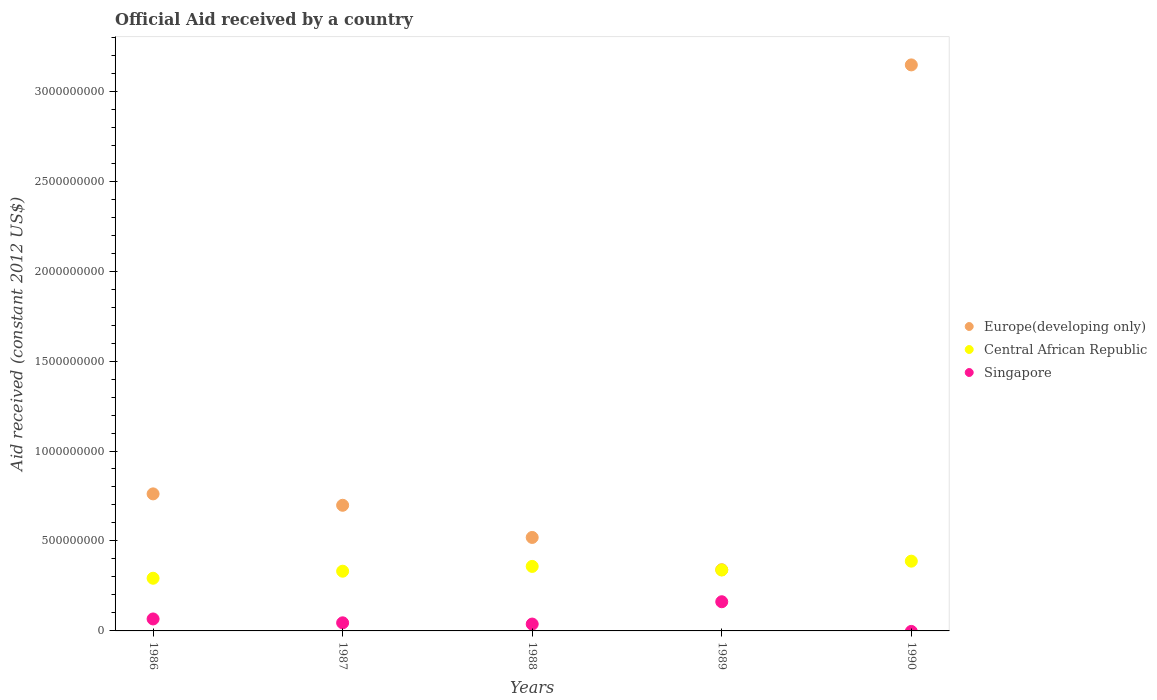What is the net official aid received in Central African Republic in 1986?
Give a very brief answer. 2.93e+08. Across all years, what is the maximum net official aid received in Europe(developing only)?
Keep it short and to the point. 3.15e+09. Across all years, what is the minimum net official aid received in Europe(developing only)?
Keep it short and to the point. 3.40e+08. What is the total net official aid received in Singapore in the graph?
Your answer should be very brief. 3.12e+08. What is the difference between the net official aid received in Europe(developing only) in 1986 and that in 1989?
Your response must be concise. 4.22e+08. What is the difference between the net official aid received in Europe(developing only) in 1986 and the net official aid received in Singapore in 1990?
Ensure brevity in your answer.  7.62e+08. What is the average net official aid received in Singapore per year?
Keep it short and to the point. 6.24e+07. In the year 1990, what is the difference between the net official aid received in Europe(developing only) and net official aid received in Central African Republic?
Keep it short and to the point. 2.76e+09. In how many years, is the net official aid received in Singapore greater than 3100000000 US$?
Ensure brevity in your answer.  0. What is the ratio of the net official aid received in Central African Republic in 1987 to that in 1988?
Your answer should be compact. 0.93. What is the difference between the highest and the second highest net official aid received in Singapore?
Provide a short and direct response. 9.56e+07. What is the difference between the highest and the lowest net official aid received in Singapore?
Ensure brevity in your answer.  1.62e+08. Is the sum of the net official aid received in Central African Republic in 1988 and 1989 greater than the maximum net official aid received in Singapore across all years?
Offer a terse response. Yes. Is it the case that in every year, the sum of the net official aid received in Central African Republic and net official aid received in Singapore  is greater than the net official aid received in Europe(developing only)?
Offer a very short reply. No. Is the net official aid received in Singapore strictly greater than the net official aid received in Central African Republic over the years?
Your answer should be compact. No. Are the values on the major ticks of Y-axis written in scientific E-notation?
Offer a terse response. No. Where does the legend appear in the graph?
Provide a short and direct response. Center right. How many legend labels are there?
Offer a terse response. 3. How are the legend labels stacked?
Your response must be concise. Vertical. What is the title of the graph?
Give a very brief answer. Official Aid received by a country. Does "High income: nonOECD" appear as one of the legend labels in the graph?
Provide a short and direct response. No. What is the label or title of the X-axis?
Your response must be concise. Years. What is the label or title of the Y-axis?
Your answer should be compact. Aid received (constant 2012 US$). What is the Aid received (constant 2012 US$) of Europe(developing only) in 1986?
Provide a succinct answer. 7.62e+08. What is the Aid received (constant 2012 US$) in Central African Republic in 1986?
Ensure brevity in your answer.  2.93e+08. What is the Aid received (constant 2012 US$) in Singapore in 1986?
Make the answer very short. 6.65e+07. What is the Aid received (constant 2012 US$) in Europe(developing only) in 1987?
Your response must be concise. 6.98e+08. What is the Aid received (constant 2012 US$) in Central African Republic in 1987?
Your response must be concise. 3.32e+08. What is the Aid received (constant 2012 US$) of Singapore in 1987?
Keep it short and to the point. 4.50e+07. What is the Aid received (constant 2012 US$) in Europe(developing only) in 1988?
Ensure brevity in your answer.  5.20e+08. What is the Aid received (constant 2012 US$) of Central African Republic in 1988?
Provide a short and direct response. 3.59e+08. What is the Aid received (constant 2012 US$) of Singapore in 1988?
Keep it short and to the point. 3.82e+07. What is the Aid received (constant 2012 US$) in Europe(developing only) in 1989?
Your answer should be compact. 3.40e+08. What is the Aid received (constant 2012 US$) of Central African Republic in 1989?
Provide a succinct answer. 3.39e+08. What is the Aid received (constant 2012 US$) in Singapore in 1989?
Provide a succinct answer. 1.62e+08. What is the Aid received (constant 2012 US$) of Europe(developing only) in 1990?
Provide a succinct answer. 3.15e+09. What is the Aid received (constant 2012 US$) in Central African Republic in 1990?
Your answer should be very brief. 3.88e+08. What is the Aid received (constant 2012 US$) of Singapore in 1990?
Make the answer very short. 0. Across all years, what is the maximum Aid received (constant 2012 US$) in Europe(developing only)?
Make the answer very short. 3.15e+09. Across all years, what is the maximum Aid received (constant 2012 US$) in Central African Republic?
Offer a terse response. 3.88e+08. Across all years, what is the maximum Aid received (constant 2012 US$) of Singapore?
Offer a very short reply. 1.62e+08. Across all years, what is the minimum Aid received (constant 2012 US$) of Europe(developing only)?
Provide a succinct answer. 3.40e+08. Across all years, what is the minimum Aid received (constant 2012 US$) of Central African Republic?
Provide a succinct answer. 2.93e+08. What is the total Aid received (constant 2012 US$) in Europe(developing only) in the graph?
Offer a terse response. 5.47e+09. What is the total Aid received (constant 2012 US$) in Central African Republic in the graph?
Keep it short and to the point. 1.71e+09. What is the total Aid received (constant 2012 US$) in Singapore in the graph?
Ensure brevity in your answer.  3.12e+08. What is the difference between the Aid received (constant 2012 US$) of Europe(developing only) in 1986 and that in 1987?
Give a very brief answer. 6.33e+07. What is the difference between the Aid received (constant 2012 US$) in Central African Republic in 1986 and that in 1987?
Your answer should be compact. -3.91e+07. What is the difference between the Aid received (constant 2012 US$) in Singapore in 1986 and that in 1987?
Offer a very short reply. 2.15e+07. What is the difference between the Aid received (constant 2012 US$) of Europe(developing only) in 1986 and that in 1988?
Your answer should be very brief. 2.42e+08. What is the difference between the Aid received (constant 2012 US$) of Central African Republic in 1986 and that in 1988?
Offer a terse response. -6.58e+07. What is the difference between the Aid received (constant 2012 US$) of Singapore in 1986 and that in 1988?
Ensure brevity in your answer.  2.84e+07. What is the difference between the Aid received (constant 2012 US$) of Europe(developing only) in 1986 and that in 1989?
Your response must be concise. 4.22e+08. What is the difference between the Aid received (constant 2012 US$) in Central African Republic in 1986 and that in 1989?
Your answer should be compact. -4.58e+07. What is the difference between the Aid received (constant 2012 US$) in Singapore in 1986 and that in 1989?
Provide a short and direct response. -9.56e+07. What is the difference between the Aid received (constant 2012 US$) of Europe(developing only) in 1986 and that in 1990?
Give a very brief answer. -2.38e+09. What is the difference between the Aid received (constant 2012 US$) of Central African Republic in 1986 and that in 1990?
Provide a succinct answer. -9.49e+07. What is the difference between the Aid received (constant 2012 US$) of Europe(developing only) in 1987 and that in 1988?
Make the answer very short. 1.79e+08. What is the difference between the Aid received (constant 2012 US$) of Central African Republic in 1987 and that in 1988?
Offer a very short reply. -2.67e+07. What is the difference between the Aid received (constant 2012 US$) of Singapore in 1987 and that in 1988?
Your response must be concise. 6.88e+06. What is the difference between the Aid received (constant 2012 US$) of Europe(developing only) in 1987 and that in 1989?
Offer a terse response. 3.58e+08. What is the difference between the Aid received (constant 2012 US$) of Central African Republic in 1987 and that in 1989?
Make the answer very short. -6.66e+06. What is the difference between the Aid received (constant 2012 US$) in Singapore in 1987 and that in 1989?
Offer a terse response. -1.17e+08. What is the difference between the Aid received (constant 2012 US$) of Europe(developing only) in 1987 and that in 1990?
Offer a terse response. -2.45e+09. What is the difference between the Aid received (constant 2012 US$) in Central African Republic in 1987 and that in 1990?
Offer a terse response. -5.58e+07. What is the difference between the Aid received (constant 2012 US$) of Europe(developing only) in 1988 and that in 1989?
Ensure brevity in your answer.  1.79e+08. What is the difference between the Aid received (constant 2012 US$) of Central African Republic in 1988 and that in 1989?
Your response must be concise. 2.00e+07. What is the difference between the Aid received (constant 2012 US$) in Singapore in 1988 and that in 1989?
Your response must be concise. -1.24e+08. What is the difference between the Aid received (constant 2012 US$) in Europe(developing only) in 1988 and that in 1990?
Your response must be concise. -2.63e+09. What is the difference between the Aid received (constant 2012 US$) in Central African Republic in 1988 and that in 1990?
Your answer should be very brief. -2.91e+07. What is the difference between the Aid received (constant 2012 US$) of Europe(developing only) in 1989 and that in 1990?
Ensure brevity in your answer.  -2.81e+09. What is the difference between the Aid received (constant 2012 US$) in Central African Republic in 1989 and that in 1990?
Give a very brief answer. -4.92e+07. What is the difference between the Aid received (constant 2012 US$) of Europe(developing only) in 1986 and the Aid received (constant 2012 US$) of Central African Republic in 1987?
Provide a succinct answer. 4.30e+08. What is the difference between the Aid received (constant 2012 US$) in Europe(developing only) in 1986 and the Aid received (constant 2012 US$) in Singapore in 1987?
Offer a terse response. 7.17e+08. What is the difference between the Aid received (constant 2012 US$) in Central African Republic in 1986 and the Aid received (constant 2012 US$) in Singapore in 1987?
Ensure brevity in your answer.  2.48e+08. What is the difference between the Aid received (constant 2012 US$) of Europe(developing only) in 1986 and the Aid received (constant 2012 US$) of Central African Republic in 1988?
Ensure brevity in your answer.  4.03e+08. What is the difference between the Aid received (constant 2012 US$) in Europe(developing only) in 1986 and the Aid received (constant 2012 US$) in Singapore in 1988?
Make the answer very short. 7.24e+08. What is the difference between the Aid received (constant 2012 US$) in Central African Republic in 1986 and the Aid received (constant 2012 US$) in Singapore in 1988?
Provide a short and direct response. 2.55e+08. What is the difference between the Aid received (constant 2012 US$) of Europe(developing only) in 1986 and the Aid received (constant 2012 US$) of Central African Republic in 1989?
Provide a short and direct response. 4.23e+08. What is the difference between the Aid received (constant 2012 US$) in Europe(developing only) in 1986 and the Aid received (constant 2012 US$) in Singapore in 1989?
Offer a terse response. 6.00e+08. What is the difference between the Aid received (constant 2012 US$) in Central African Republic in 1986 and the Aid received (constant 2012 US$) in Singapore in 1989?
Your response must be concise. 1.31e+08. What is the difference between the Aid received (constant 2012 US$) of Europe(developing only) in 1986 and the Aid received (constant 2012 US$) of Central African Republic in 1990?
Offer a terse response. 3.74e+08. What is the difference between the Aid received (constant 2012 US$) of Europe(developing only) in 1987 and the Aid received (constant 2012 US$) of Central African Republic in 1988?
Provide a short and direct response. 3.40e+08. What is the difference between the Aid received (constant 2012 US$) in Europe(developing only) in 1987 and the Aid received (constant 2012 US$) in Singapore in 1988?
Your response must be concise. 6.60e+08. What is the difference between the Aid received (constant 2012 US$) in Central African Republic in 1987 and the Aid received (constant 2012 US$) in Singapore in 1988?
Keep it short and to the point. 2.94e+08. What is the difference between the Aid received (constant 2012 US$) in Europe(developing only) in 1987 and the Aid received (constant 2012 US$) in Central African Republic in 1989?
Provide a succinct answer. 3.60e+08. What is the difference between the Aid received (constant 2012 US$) in Europe(developing only) in 1987 and the Aid received (constant 2012 US$) in Singapore in 1989?
Keep it short and to the point. 5.36e+08. What is the difference between the Aid received (constant 2012 US$) of Central African Republic in 1987 and the Aid received (constant 2012 US$) of Singapore in 1989?
Ensure brevity in your answer.  1.70e+08. What is the difference between the Aid received (constant 2012 US$) of Europe(developing only) in 1987 and the Aid received (constant 2012 US$) of Central African Republic in 1990?
Offer a terse response. 3.11e+08. What is the difference between the Aid received (constant 2012 US$) of Europe(developing only) in 1988 and the Aid received (constant 2012 US$) of Central African Republic in 1989?
Make the answer very short. 1.81e+08. What is the difference between the Aid received (constant 2012 US$) of Europe(developing only) in 1988 and the Aid received (constant 2012 US$) of Singapore in 1989?
Your answer should be very brief. 3.57e+08. What is the difference between the Aid received (constant 2012 US$) in Central African Republic in 1988 and the Aid received (constant 2012 US$) in Singapore in 1989?
Your response must be concise. 1.96e+08. What is the difference between the Aid received (constant 2012 US$) of Europe(developing only) in 1988 and the Aid received (constant 2012 US$) of Central African Republic in 1990?
Your answer should be compact. 1.32e+08. What is the difference between the Aid received (constant 2012 US$) of Europe(developing only) in 1989 and the Aid received (constant 2012 US$) of Central African Republic in 1990?
Make the answer very short. -4.76e+07. What is the average Aid received (constant 2012 US$) of Europe(developing only) per year?
Provide a short and direct response. 1.09e+09. What is the average Aid received (constant 2012 US$) of Central African Republic per year?
Keep it short and to the point. 3.42e+08. What is the average Aid received (constant 2012 US$) in Singapore per year?
Offer a terse response. 6.24e+07. In the year 1986, what is the difference between the Aid received (constant 2012 US$) of Europe(developing only) and Aid received (constant 2012 US$) of Central African Republic?
Provide a short and direct response. 4.69e+08. In the year 1986, what is the difference between the Aid received (constant 2012 US$) of Europe(developing only) and Aid received (constant 2012 US$) of Singapore?
Provide a short and direct response. 6.95e+08. In the year 1986, what is the difference between the Aid received (constant 2012 US$) in Central African Republic and Aid received (constant 2012 US$) in Singapore?
Ensure brevity in your answer.  2.26e+08. In the year 1987, what is the difference between the Aid received (constant 2012 US$) in Europe(developing only) and Aid received (constant 2012 US$) in Central African Republic?
Your answer should be very brief. 3.66e+08. In the year 1987, what is the difference between the Aid received (constant 2012 US$) of Europe(developing only) and Aid received (constant 2012 US$) of Singapore?
Your response must be concise. 6.53e+08. In the year 1987, what is the difference between the Aid received (constant 2012 US$) in Central African Republic and Aid received (constant 2012 US$) in Singapore?
Ensure brevity in your answer.  2.87e+08. In the year 1988, what is the difference between the Aid received (constant 2012 US$) of Europe(developing only) and Aid received (constant 2012 US$) of Central African Republic?
Your answer should be compact. 1.61e+08. In the year 1988, what is the difference between the Aid received (constant 2012 US$) in Europe(developing only) and Aid received (constant 2012 US$) in Singapore?
Keep it short and to the point. 4.81e+08. In the year 1988, what is the difference between the Aid received (constant 2012 US$) in Central African Republic and Aid received (constant 2012 US$) in Singapore?
Ensure brevity in your answer.  3.20e+08. In the year 1989, what is the difference between the Aid received (constant 2012 US$) of Europe(developing only) and Aid received (constant 2012 US$) of Central African Republic?
Your response must be concise. 1.56e+06. In the year 1989, what is the difference between the Aid received (constant 2012 US$) of Europe(developing only) and Aid received (constant 2012 US$) of Singapore?
Your answer should be compact. 1.78e+08. In the year 1989, what is the difference between the Aid received (constant 2012 US$) of Central African Republic and Aid received (constant 2012 US$) of Singapore?
Keep it short and to the point. 1.76e+08. In the year 1990, what is the difference between the Aid received (constant 2012 US$) of Europe(developing only) and Aid received (constant 2012 US$) of Central African Republic?
Offer a terse response. 2.76e+09. What is the ratio of the Aid received (constant 2012 US$) in Europe(developing only) in 1986 to that in 1987?
Your response must be concise. 1.09. What is the ratio of the Aid received (constant 2012 US$) of Central African Republic in 1986 to that in 1987?
Your response must be concise. 0.88. What is the ratio of the Aid received (constant 2012 US$) of Singapore in 1986 to that in 1987?
Keep it short and to the point. 1.48. What is the ratio of the Aid received (constant 2012 US$) of Europe(developing only) in 1986 to that in 1988?
Your response must be concise. 1.47. What is the ratio of the Aid received (constant 2012 US$) of Central African Republic in 1986 to that in 1988?
Provide a short and direct response. 0.82. What is the ratio of the Aid received (constant 2012 US$) of Singapore in 1986 to that in 1988?
Offer a very short reply. 1.74. What is the ratio of the Aid received (constant 2012 US$) of Europe(developing only) in 1986 to that in 1989?
Provide a short and direct response. 2.24. What is the ratio of the Aid received (constant 2012 US$) of Central African Republic in 1986 to that in 1989?
Ensure brevity in your answer.  0.86. What is the ratio of the Aid received (constant 2012 US$) in Singapore in 1986 to that in 1989?
Keep it short and to the point. 0.41. What is the ratio of the Aid received (constant 2012 US$) in Europe(developing only) in 1986 to that in 1990?
Your answer should be very brief. 0.24. What is the ratio of the Aid received (constant 2012 US$) of Central African Republic in 1986 to that in 1990?
Provide a short and direct response. 0.76. What is the ratio of the Aid received (constant 2012 US$) of Europe(developing only) in 1987 to that in 1988?
Keep it short and to the point. 1.34. What is the ratio of the Aid received (constant 2012 US$) of Central African Republic in 1987 to that in 1988?
Keep it short and to the point. 0.93. What is the ratio of the Aid received (constant 2012 US$) of Singapore in 1987 to that in 1988?
Your response must be concise. 1.18. What is the ratio of the Aid received (constant 2012 US$) of Europe(developing only) in 1987 to that in 1989?
Ensure brevity in your answer.  2.05. What is the ratio of the Aid received (constant 2012 US$) in Central African Republic in 1987 to that in 1989?
Your answer should be compact. 0.98. What is the ratio of the Aid received (constant 2012 US$) of Singapore in 1987 to that in 1989?
Your answer should be very brief. 0.28. What is the ratio of the Aid received (constant 2012 US$) of Europe(developing only) in 1987 to that in 1990?
Provide a succinct answer. 0.22. What is the ratio of the Aid received (constant 2012 US$) in Central African Republic in 1987 to that in 1990?
Ensure brevity in your answer.  0.86. What is the ratio of the Aid received (constant 2012 US$) in Europe(developing only) in 1988 to that in 1989?
Offer a very short reply. 1.53. What is the ratio of the Aid received (constant 2012 US$) in Central African Republic in 1988 to that in 1989?
Provide a short and direct response. 1.06. What is the ratio of the Aid received (constant 2012 US$) of Singapore in 1988 to that in 1989?
Keep it short and to the point. 0.24. What is the ratio of the Aid received (constant 2012 US$) of Europe(developing only) in 1988 to that in 1990?
Your answer should be compact. 0.17. What is the ratio of the Aid received (constant 2012 US$) in Central African Republic in 1988 to that in 1990?
Keep it short and to the point. 0.92. What is the ratio of the Aid received (constant 2012 US$) in Europe(developing only) in 1989 to that in 1990?
Ensure brevity in your answer.  0.11. What is the ratio of the Aid received (constant 2012 US$) of Central African Republic in 1989 to that in 1990?
Offer a terse response. 0.87. What is the difference between the highest and the second highest Aid received (constant 2012 US$) in Europe(developing only)?
Offer a very short reply. 2.38e+09. What is the difference between the highest and the second highest Aid received (constant 2012 US$) of Central African Republic?
Provide a succinct answer. 2.91e+07. What is the difference between the highest and the second highest Aid received (constant 2012 US$) of Singapore?
Your response must be concise. 9.56e+07. What is the difference between the highest and the lowest Aid received (constant 2012 US$) of Europe(developing only)?
Keep it short and to the point. 2.81e+09. What is the difference between the highest and the lowest Aid received (constant 2012 US$) in Central African Republic?
Provide a succinct answer. 9.49e+07. What is the difference between the highest and the lowest Aid received (constant 2012 US$) in Singapore?
Ensure brevity in your answer.  1.62e+08. 